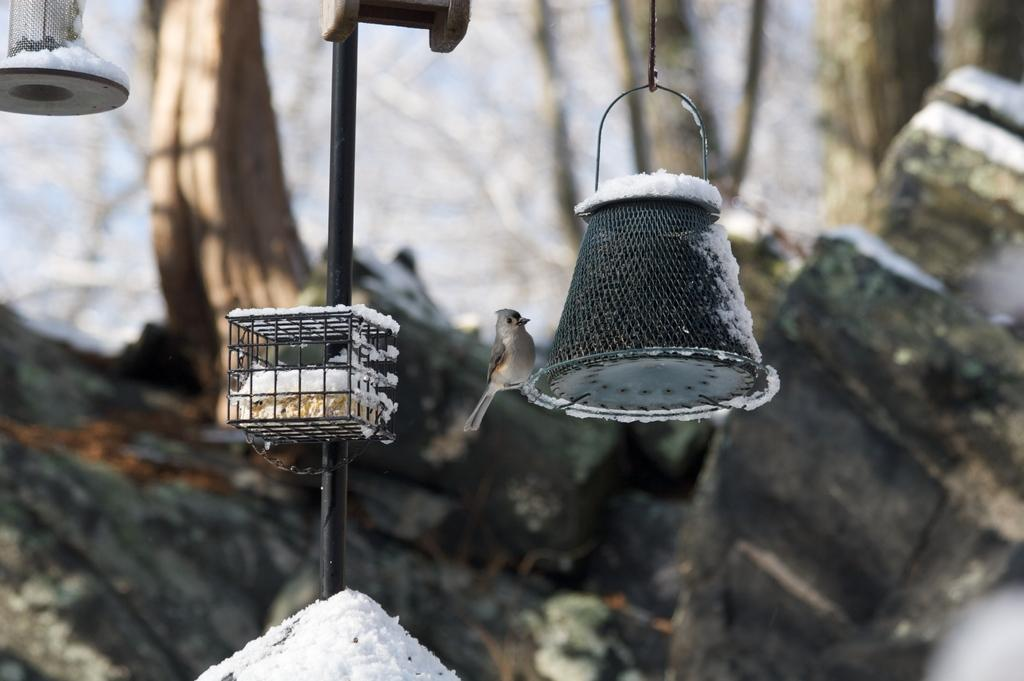What is the bird perched on in the image? The bird is on an object in the image. What type of weather is depicted in the image? There is snow visible in the image. What can be seen on the pole in the image? There is a pole with an object in the image, and the object looks like a cage. How would you describe the background of the image? The background of the image is blurred. How many dogs are playing with the baby in the image? There are no dogs or babies present in the image; it features a bird on an object with snow in the background. 